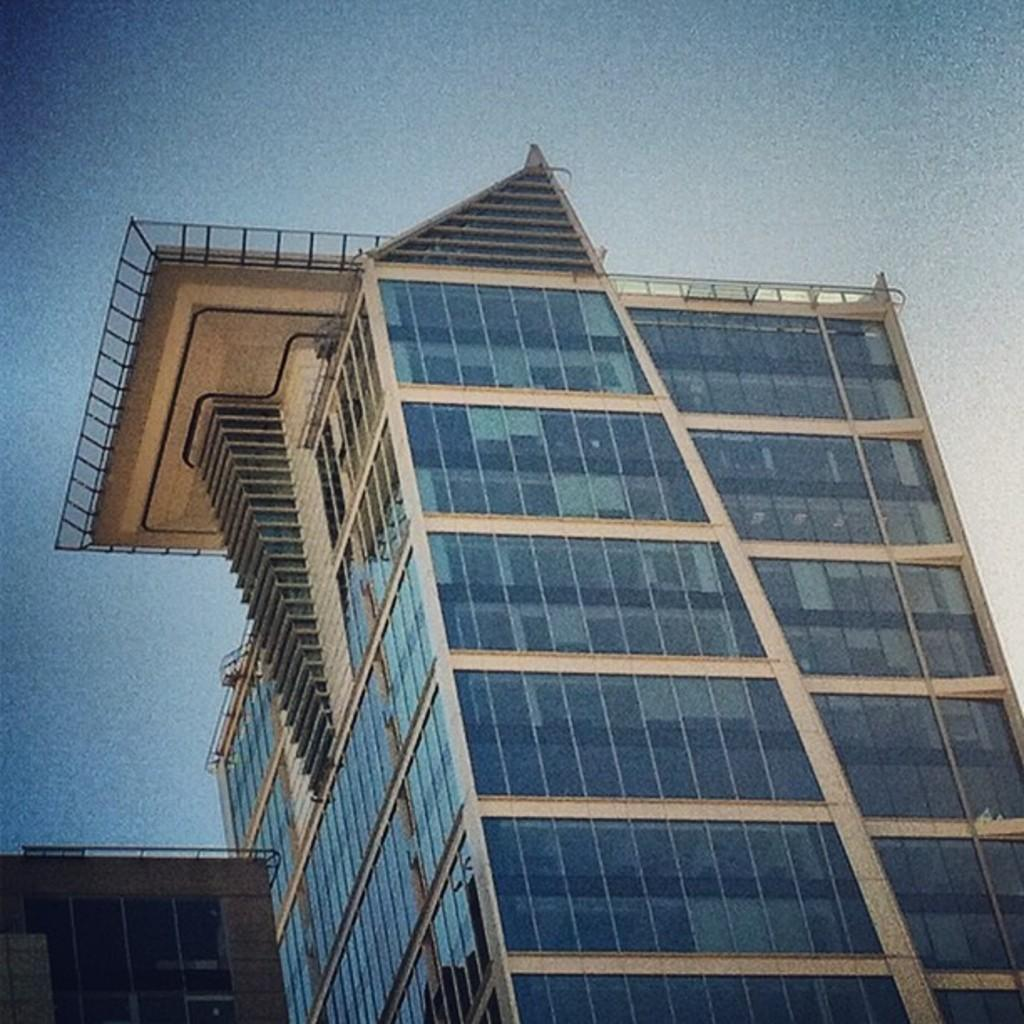How many buildings can be seen in the image? There are two buildings in the image. What is visible at the top of the image? The sky is visible at the top of the image. Can you see a zephyr flying in the image? There is no zephyr present in the image. A zephyr is a gentle breeze, not a visible object that can be seen in an image. 